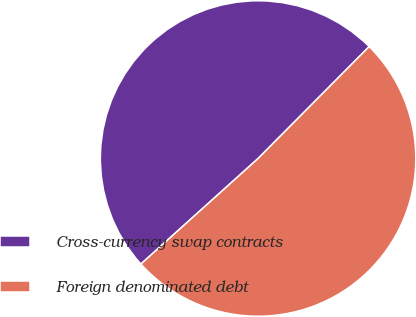Convert chart. <chart><loc_0><loc_0><loc_500><loc_500><pie_chart><fcel>Cross-currency swap contracts<fcel>Foreign denominated debt<nl><fcel>49.11%<fcel>50.89%<nl></chart> 